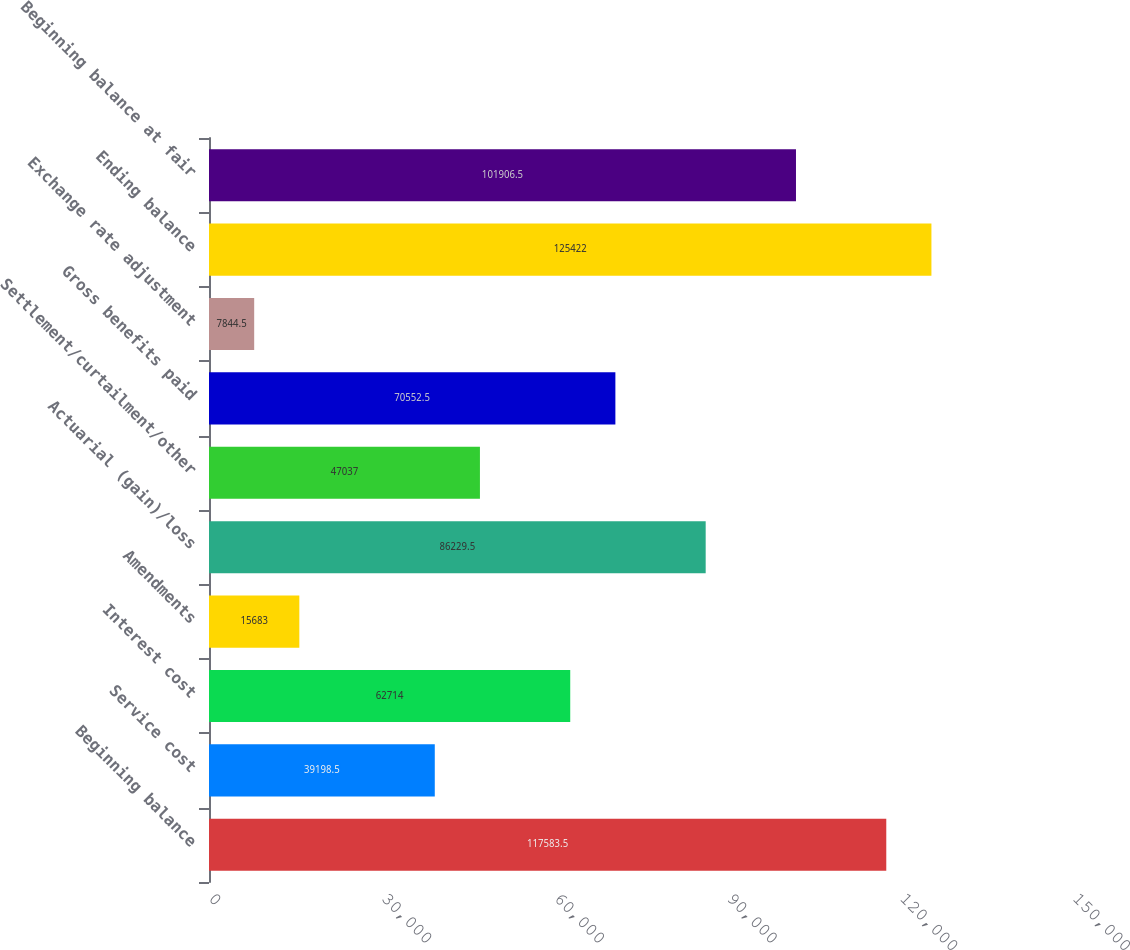Convert chart. <chart><loc_0><loc_0><loc_500><loc_500><bar_chart><fcel>Beginning balance<fcel>Service cost<fcel>Interest cost<fcel>Amendments<fcel>Actuarial (gain)/loss<fcel>Settlement/curtailment/other<fcel>Gross benefits paid<fcel>Exchange rate adjustment<fcel>Ending balance<fcel>Beginning balance at fair<nl><fcel>117584<fcel>39198.5<fcel>62714<fcel>15683<fcel>86229.5<fcel>47037<fcel>70552.5<fcel>7844.5<fcel>125422<fcel>101906<nl></chart> 